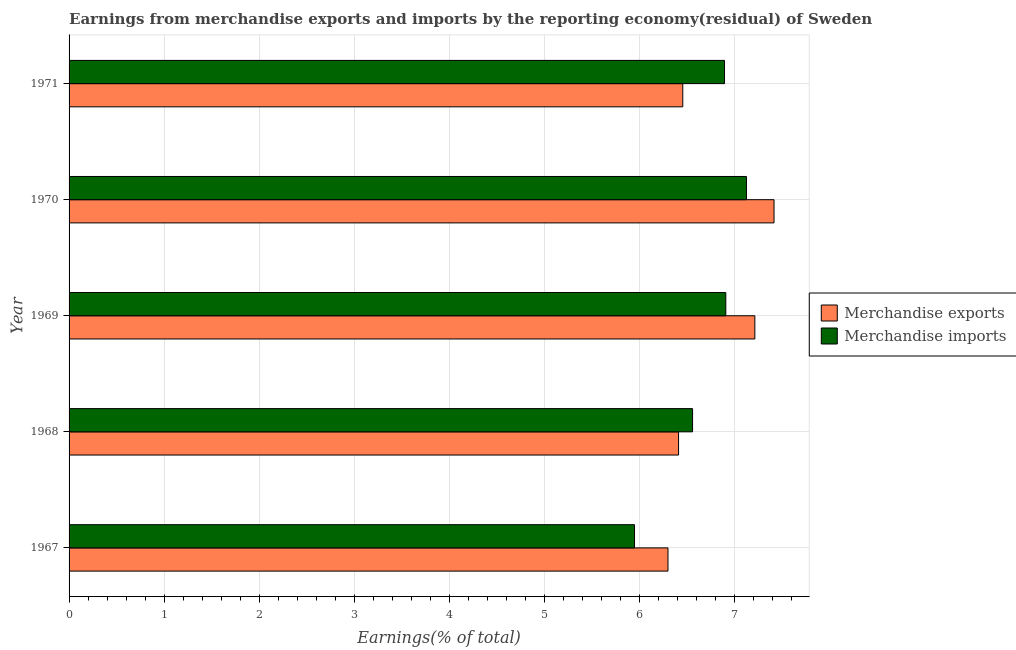Are the number of bars per tick equal to the number of legend labels?
Your answer should be very brief. Yes. How many bars are there on the 5th tick from the bottom?
Offer a terse response. 2. What is the label of the 1st group of bars from the top?
Your response must be concise. 1971. What is the earnings from merchandise imports in 1968?
Ensure brevity in your answer.  6.56. Across all years, what is the maximum earnings from merchandise imports?
Your response must be concise. 7.13. Across all years, what is the minimum earnings from merchandise exports?
Keep it short and to the point. 6.3. In which year was the earnings from merchandise imports minimum?
Offer a very short reply. 1967. What is the total earnings from merchandise exports in the graph?
Offer a very short reply. 33.81. What is the difference between the earnings from merchandise exports in 1970 and that in 1971?
Offer a terse response. 0.96. What is the difference between the earnings from merchandise imports in 1968 and the earnings from merchandise exports in 1970?
Provide a succinct answer. -0.86. What is the average earnings from merchandise exports per year?
Give a very brief answer. 6.76. In the year 1971, what is the difference between the earnings from merchandise exports and earnings from merchandise imports?
Keep it short and to the point. -0.44. What is the ratio of the earnings from merchandise exports in 1967 to that in 1968?
Provide a succinct answer. 0.98. What is the difference between the highest and the second highest earnings from merchandise imports?
Offer a terse response. 0.22. What is the difference between the highest and the lowest earnings from merchandise exports?
Offer a very short reply. 1.12. What does the 1st bar from the bottom in 1970 represents?
Your answer should be very brief. Merchandise exports. How many bars are there?
Provide a short and direct response. 10. How many years are there in the graph?
Ensure brevity in your answer.  5. Are the values on the major ticks of X-axis written in scientific E-notation?
Your answer should be compact. No. Does the graph contain any zero values?
Offer a terse response. No. How many legend labels are there?
Provide a succinct answer. 2. What is the title of the graph?
Offer a terse response. Earnings from merchandise exports and imports by the reporting economy(residual) of Sweden. What is the label or title of the X-axis?
Offer a very short reply. Earnings(% of total). What is the label or title of the Y-axis?
Your answer should be compact. Year. What is the Earnings(% of total) of Merchandise exports in 1967?
Provide a succinct answer. 6.3. What is the Earnings(% of total) of Merchandise imports in 1967?
Your response must be concise. 5.95. What is the Earnings(% of total) of Merchandise exports in 1968?
Provide a short and direct response. 6.41. What is the Earnings(% of total) in Merchandise imports in 1968?
Ensure brevity in your answer.  6.56. What is the Earnings(% of total) in Merchandise exports in 1969?
Provide a succinct answer. 7.22. What is the Earnings(% of total) in Merchandise imports in 1969?
Provide a short and direct response. 6.91. What is the Earnings(% of total) of Merchandise exports in 1970?
Offer a very short reply. 7.42. What is the Earnings(% of total) of Merchandise imports in 1970?
Provide a succinct answer. 7.13. What is the Earnings(% of total) in Merchandise exports in 1971?
Provide a succinct answer. 6.46. What is the Earnings(% of total) in Merchandise imports in 1971?
Offer a very short reply. 6.9. Across all years, what is the maximum Earnings(% of total) in Merchandise exports?
Offer a terse response. 7.42. Across all years, what is the maximum Earnings(% of total) in Merchandise imports?
Ensure brevity in your answer.  7.13. Across all years, what is the minimum Earnings(% of total) of Merchandise exports?
Keep it short and to the point. 6.3. Across all years, what is the minimum Earnings(% of total) in Merchandise imports?
Make the answer very short. 5.95. What is the total Earnings(% of total) in Merchandise exports in the graph?
Provide a succinct answer. 33.81. What is the total Earnings(% of total) in Merchandise imports in the graph?
Make the answer very short. 33.44. What is the difference between the Earnings(% of total) of Merchandise exports in 1967 and that in 1968?
Offer a terse response. -0.11. What is the difference between the Earnings(% of total) in Merchandise imports in 1967 and that in 1968?
Ensure brevity in your answer.  -0.61. What is the difference between the Earnings(% of total) in Merchandise exports in 1967 and that in 1969?
Give a very brief answer. -0.91. What is the difference between the Earnings(% of total) in Merchandise imports in 1967 and that in 1969?
Offer a very short reply. -0.96. What is the difference between the Earnings(% of total) of Merchandise exports in 1967 and that in 1970?
Give a very brief answer. -1.12. What is the difference between the Earnings(% of total) of Merchandise imports in 1967 and that in 1970?
Keep it short and to the point. -1.18. What is the difference between the Earnings(% of total) of Merchandise exports in 1967 and that in 1971?
Keep it short and to the point. -0.16. What is the difference between the Earnings(% of total) of Merchandise imports in 1967 and that in 1971?
Offer a terse response. -0.95. What is the difference between the Earnings(% of total) in Merchandise exports in 1968 and that in 1969?
Your answer should be compact. -0.8. What is the difference between the Earnings(% of total) in Merchandise imports in 1968 and that in 1969?
Offer a terse response. -0.35. What is the difference between the Earnings(% of total) of Merchandise exports in 1968 and that in 1970?
Provide a short and direct response. -1. What is the difference between the Earnings(% of total) of Merchandise imports in 1968 and that in 1970?
Offer a terse response. -0.57. What is the difference between the Earnings(% of total) in Merchandise exports in 1968 and that in 1971?
Your answer should be very brief. -0.04. What is the difference between the Earnings(% of total) of Merchandise imports in 1968 and that in 1971?
Make the answer very short. -0.34. What is the difference between the Earnings(% of total) of Merchandise exports in 1969 and that in 1970?
Offer a terse response. -0.2. What is the difference between the Earnings(% of total) in Merchandise imports in 1969 and that in 1970?
Provide a short and direct response. -0.22. What is the difference between the Earnings(% of total) of Merchandise exports in 1969 and that in 1971?
Your response must be concise. 0.76. What is the difference between the Earnings(% of total) in Merchandise imports in 1969 and that in 1971?
Provide a short and direct response. 0.01. What is the difference between the Earnings(% of total) of Merchandise exports in 1970 and that in 1971?
Your answer should be compact. 0.96. What is the difference between the Earnings(% of total) of Merchandise imports in 1970 and that in 1971?
Offer a terse response. 0.23. What is the difference between the Earnings(% of total) of Merchandise exports in 1967 and the Earnings(% of total) of Merchandise imports in 1968?
Your response must be concise. -0.26. What is the difference between the Earnings(% of total) in Merchandise exports in 1967 and the Earnings(% of total) in Merchandise imports in 1969?
Offer a terse response. -0.61. What is the difference between the Earnings(% of total) of Merchandise exports in 1967 and the Earnings(% of total) of Merchandise imports in 1970?
Make the answer very short. -0.83. What is the difference between the Earnings(% of total) of Merchandise exports in 1967 and the Earnings(% of total) of Merchandise imports in 1971?
Your response must be concise. -0.59. What is the difference between the Earnings(% of total) in Merchandise exports in 1968 and the Earnings(% of total) in Merchandise imports in 1969?
Offer a very short reply. -0.5. What is the difference between the Earnings(% of total) in Merchandise exports in 1968 and the Earnings(% of total) in Merchandise imports in 1970?
Keep it short and to the point. -0.71. What is the difference between the Earnings(% of total) in Merchandise exports in 1968 and the Earnings(% of total) in Merchandise imports in 1971?
Offer a very short reply. -0.48. What is the difference between the Earnings(% of total) in Merchandise exports in 1969 and the Earnings(% of total) in Merchandise imports in 1970?
Your response must be concise. 0.09. What is the difference between the Earnings(% of total) of Merchandise exports in 1969 and the Earnings(% of total) of Merchandise imports in 1971?
Your response must be concise. 0.32. What is the difference between the Earnings(% of total) of Merchandise exports in 1970 and the Earnings(% of total) of Merchandise imports in 1971?
Offer a very short reply. 0.52. What is the average Earnings(% of total) of Merchandise exports per year?
Your answer should be very brief. 6.76. What is the average Earnings(% of total) in Merchandise imports per year?
Make the answer very short. 6.69. In the year 1967, what is the difference between the Earnings(% of total) in Merchandise exports and Earnings(% of total) in Merchandise imports?
Offer a very short reply. 0.35. In the year 1968, what is the difference between the Earnings(% of total) of Merchandise exports and Earnings(% of total) of Merchandise imports?
Offer a very short reply. -0.15. In the year 1969, what is the difference between the Earnings(% of total) in Merchandise exports and Earnings(% of total) in Merchandise imports?
Your answer should be very brief. 0.31. In the year 1970, what is the difference between the Earnings(% of total) of Merchandise exports and Earnings(% of total) of Merchandise imports?
Your answer should be compact. 0.29. In the year 1971, what is the difference between the Earnings(% of total) of Merchandise exports and Earnings(% of total) of Merchandise imports?
Ensure brevity in your answer.  -0.44. What is the ratio of the Earnings(% of total) of Merchandise exports in 1967 to that in 1968?
Your answer should be compact. 0.98. What is the ratio of the Earnings(% of total) in Merchandise imports in 1967 to that in 1968?
Provide a short and direct response. 0.91. What is the ratio of the Earnings(% of total) of Merchandise exports in 1967 to that in 1969?
Offer a very short reply. 0.87. What is the ratio of the Earnings(% of total) in Merchandise imports in 1967 to that in 1969?
Provide a succinct answer. 0.86. What is the ratio of the Earnings(% of total) in Merchandise exports in 1967 to that in 1970?
Your answer should be very brief. 0.85. What is the ratio of the Earnings(% of total) of Merchandise imports in 1967 to that in 1970?
Ensure brevity in your answer.  0.83. What is the ratio of the Earnings(% of total) of Merchandise exports in 1967 to that in 1971?
Your answer should be compact. 0.98. What is the ratio of the Earnings(% of total) of Merchandise imports in 1967 to that in 1971?
Make the answer very short. 0.86. What is the ratio of the Earnings(% of total) of Merchandise exports in 1968 to that in 1969?
Your response must be concise. 0.89. What is the ratio of the Earnings(% of total) in Merchandise imports in 1968 to that in 1969?
Offer a terse response. 0.95. What is the ratio of the Earnings(% of total) in Merchandise exports in 1968 to that in 1970?
Offer a very short reply. 0.86. What is the ratio of the Earnings(% of total) of Merchandise imports in 1968 to that in 1970?
Provide a short and direct response. 0.92. What is the ratio of the Earnings(% of total) of Merchandise imports in 1968 to that in 1971?
Ensure brevity in your answer.  0.95. What is the ratio of the Earnings(% of total) in Merchandise exports in 1969 to that in 1970?
Provide a succinct answer. 0.97. What is the ratio of the Earnings(% of total) in Merchandise imports in 1969 to that in 1970?
Ensure brevity in your answer.  0.97. What is the ratio of the Earnings(% of total) of Merchandise exports in 1969 to that in 1971?
Give a very brief answer. 1.12. What is the ratio of the Earnings(% of total) in Merchandise exports in 1970 to that in 1971?
Provide a short and direct response. 1.15. What is the ratio of the Earnings(% of total) of Merchandise imports in 1970 to that in 1971?
Ensure brevity in your answer.  1.03. What is the difference between the highest and the second highest Earnings(% of total) in Merchandise exports?
Your response must be concise. 0.2. What is the difference between the highest and the second highest Earnings(% of total) in Merchandise imports?
Make the answer very short. 0.22. What is the difference between the highest and the lowest Earnings(% of total) in Merchandise exports?
Keep it short and to the point. 1.12. What is the difference between the highest and the lowest Earnings(% of total) in Merchandise imports?
Your response must be concise. 1.18. 